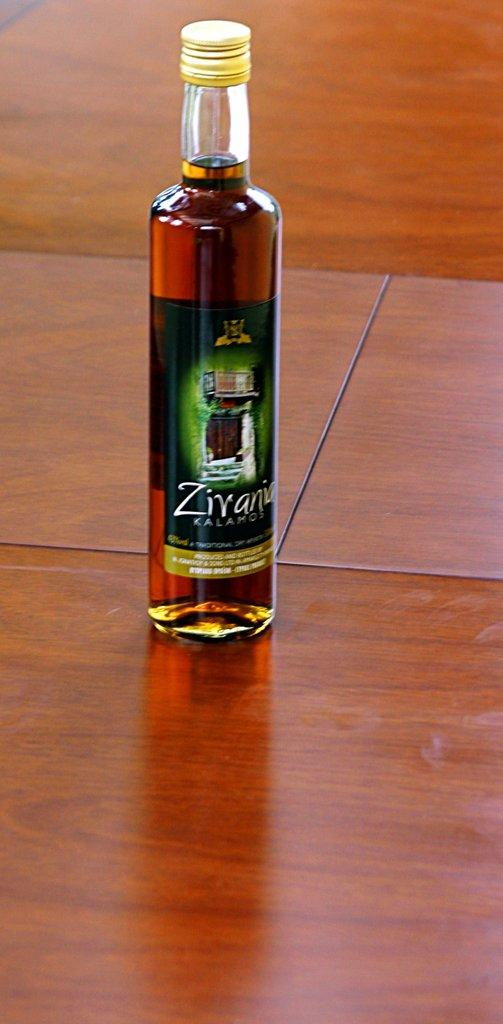<image>
Write a terse but informative summary of the picture. A bottle of Zirania Kalamo sitting alone on the table 